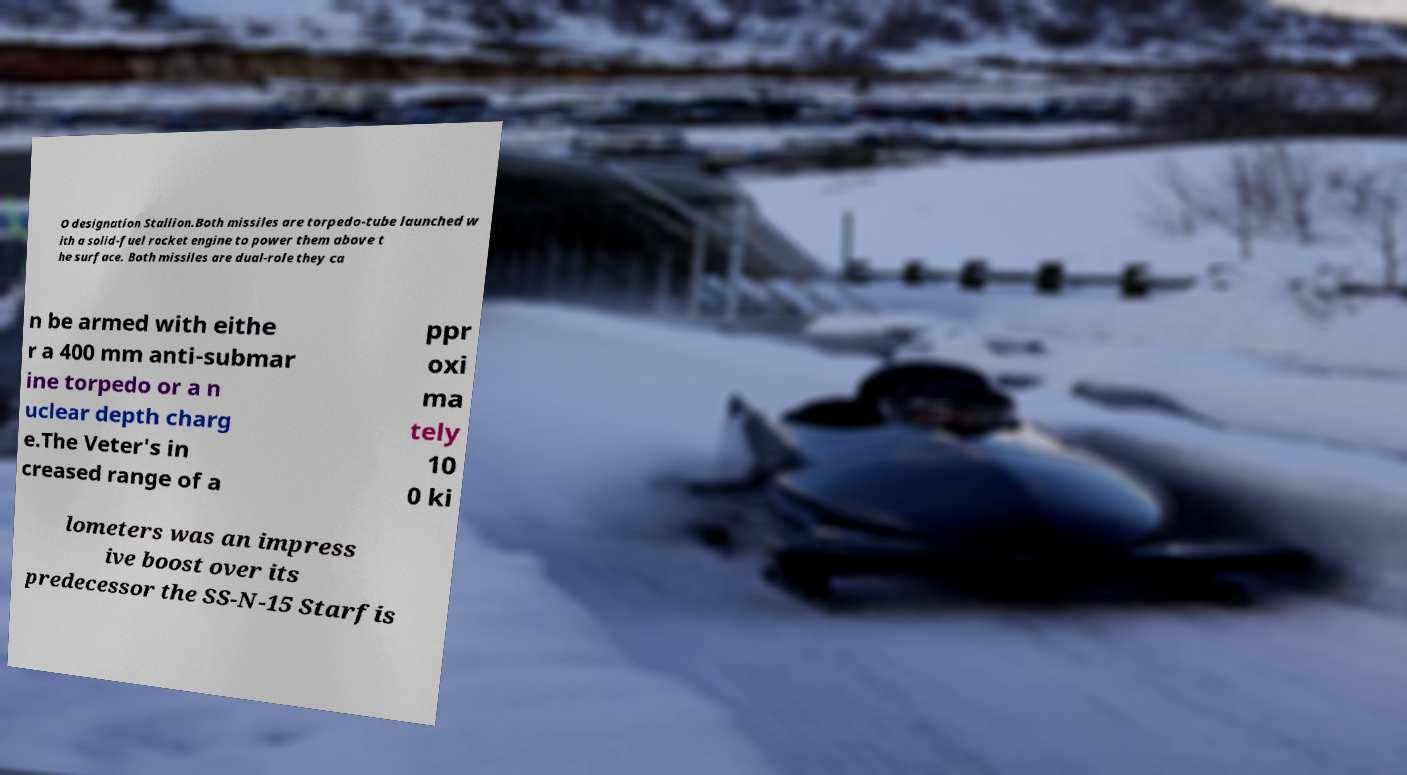I need the written content from this picture converted into text. Can you do that? O designation Stallion.Both missiles are torpedo-tube launched w ith a solid-fuel rocket engine to power them above t he surface. Both missiles are dual-role they ca n be armed with eithe r a 400 mm anti-submar ine torpedo or a n uclear depth charg e.The Veter's in creased range of a ppr oxi ma tely 10 0 ki lometers was an impress ive boost over its predecessor the SS-N-15 Starfis 